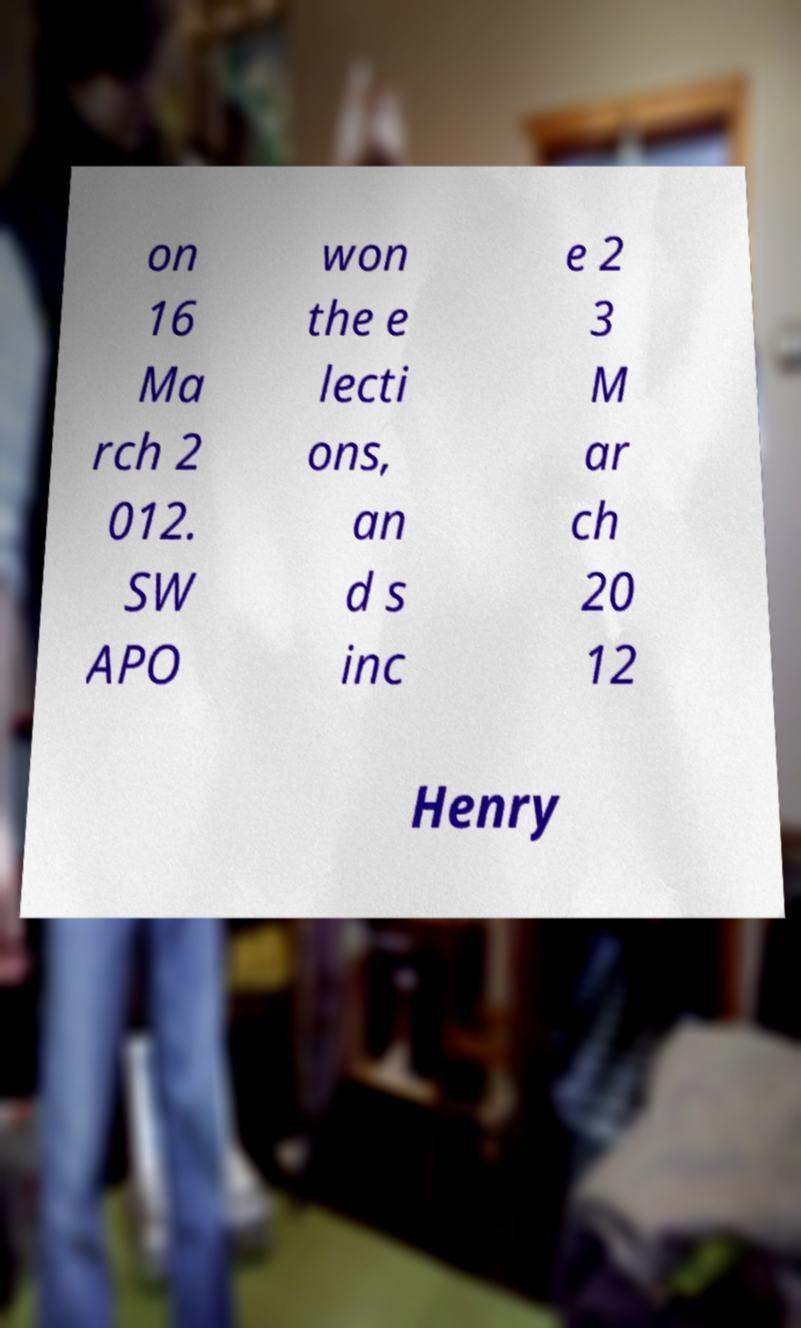Please identify and transcribe the text found in this image. on 16 Ma rch 2 012. SW APO won the e lecti ons, an d s inc e 2 3 M ar ch 20 12 Henry 